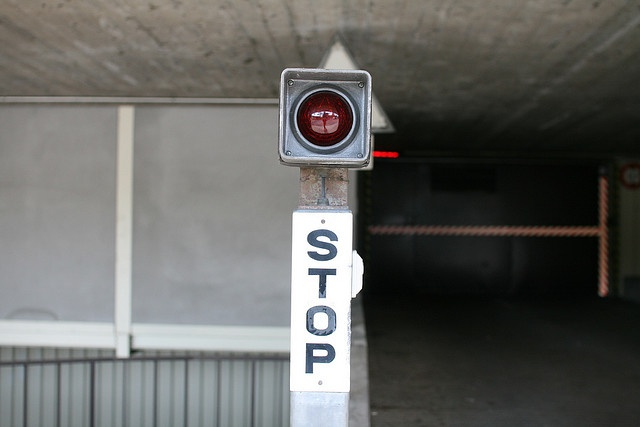Describe the objects in this image and their specific colors. I can see stop sign in gray, white, and darkgray tones and traffic light in gray, black, darkgray, and maroon tones in this image. 